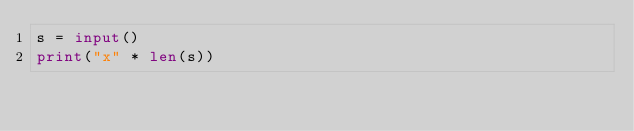Convert code to text. <code><loc_0><loc_0><loc_500><loc_500><_Python_>s = input()
print("x" * len(s))</code> 